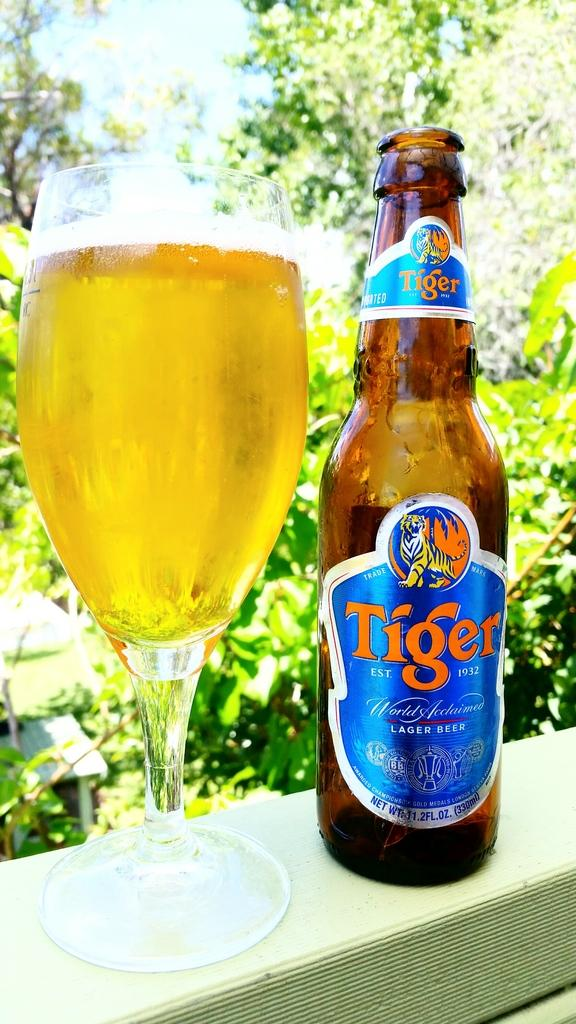<image>
Render a clear and concise summary of the photo. A bottle of Tiger Lager Beer is next to a glass. 